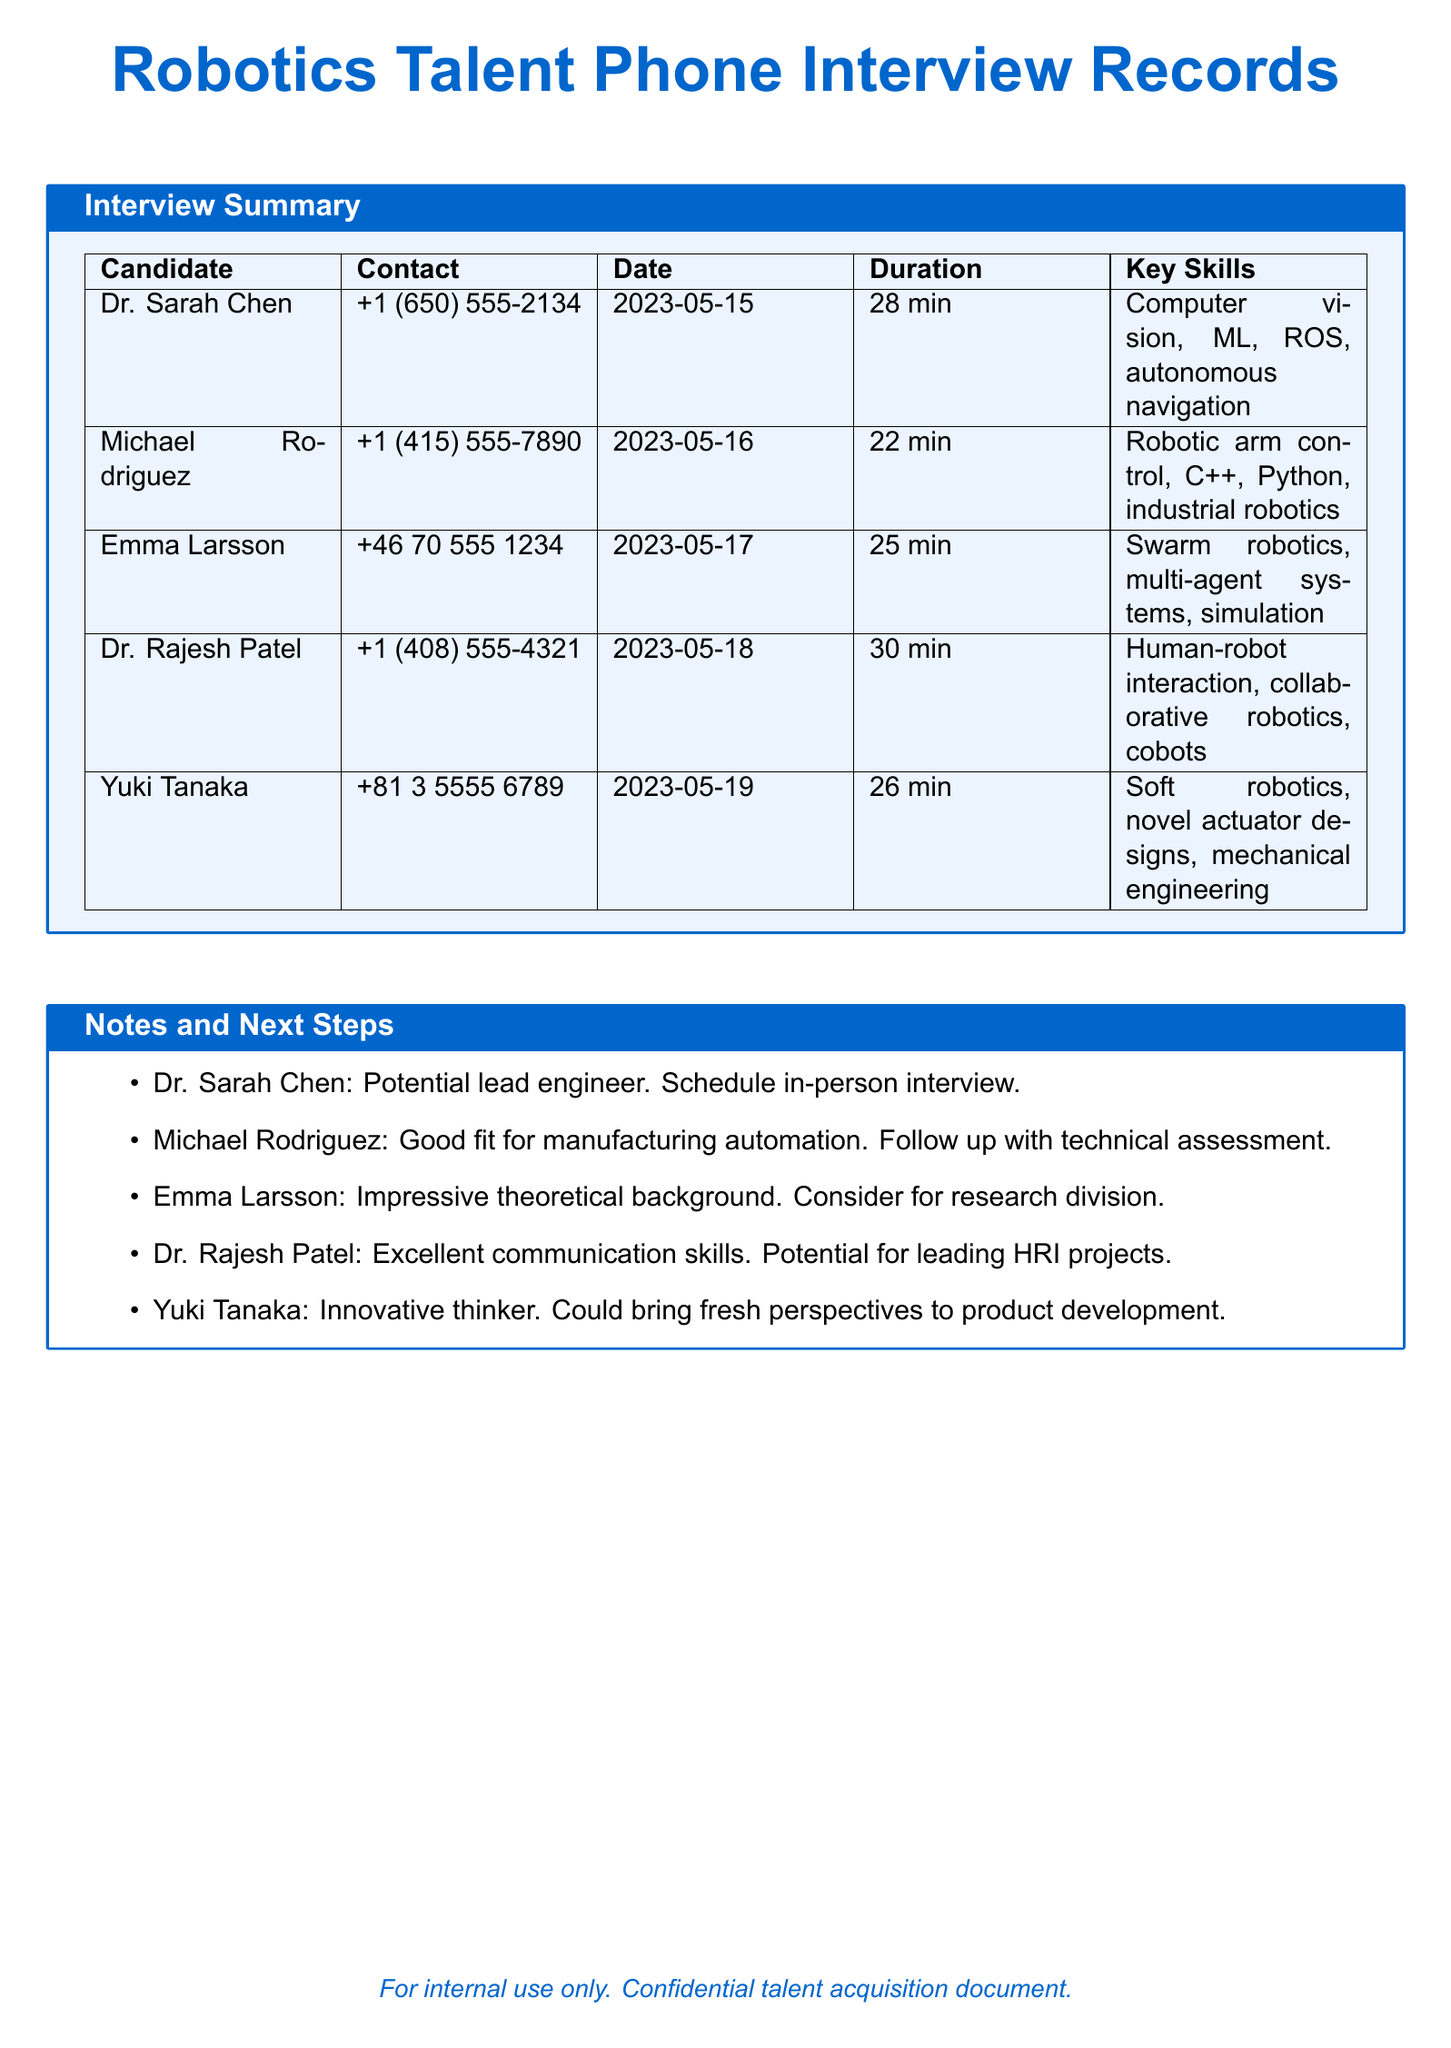What is the name of the candidate who specializes in computer vision? The name of the candidate who specializes in computer vision is Dr. Sarah Chen.
Answer: Dr. Sarah Chen How long was the interview with Michael Rodriguez? The duration of the interview with Michael Rodriguez was 22 minutes.
Answer: 22 min Which candidate has a background in swarm robotics? The candidate with a background in swarm robotics is Emma Larsson.
Answer: Emma Larsson What was the date of the interview with Dr. Rajesh Patel? The interview with Dr. Rajesh Patel took place on May 18, 2023.
Answer: 2023-05-18 Who is noted for having excellent communication skills? Dr. Rajesh Patel is noted for having excellent communication skills.
Answer: Dr. Rajesh Patel How many candidates were interviewed in total? The total number of candidates interviewed is five.
Answer: 5 What is the next step for Dr. Sarah Chen? The next step for Dr. Sarah Chen is to schedule an in-person interview.
Answer: Schedule in-person interview Which candidate could bring fresh perspectives to product development? Yuki Tanaka could bring fresh perspectives to product development.
Answer: Yuki Tanaka What programming languages is Michael Rodriguez proficient in? Michael Rodriguez is proficient in C++ and Python.
Answer: C++, Python 